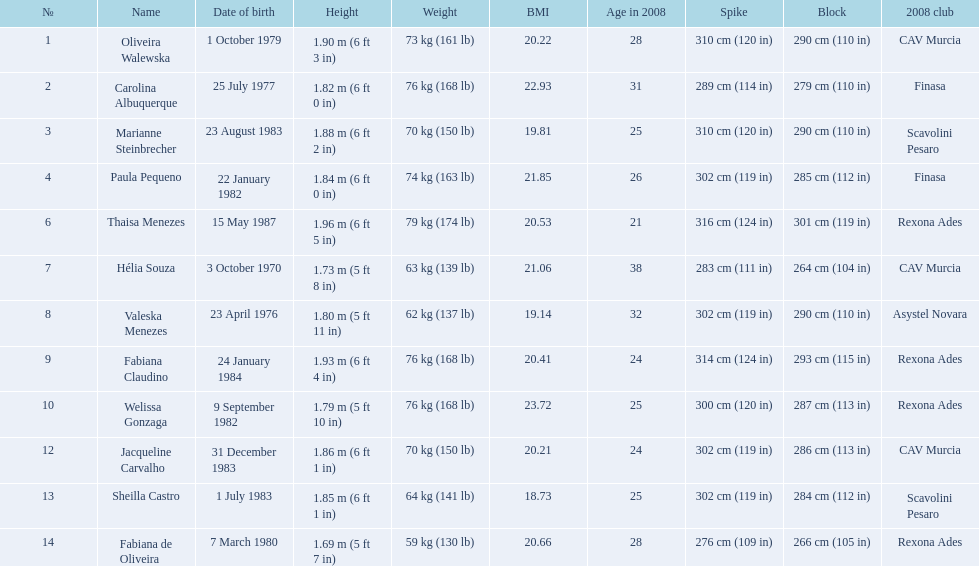What are all of the names? Oliveira Walewska, Carolina Albuquerque, Marianne Steinbrecher, Paula Pequeno, Thaisa Menezes, Hélia Souza, Valeska Menezes, Fabiana Claudino, Welissa Gonzaga, Jacqueline Carvalho, Sheilla Castro, Fabiana de Oliveira. What are their weights? 73 kg (161 lb), 76 kg (168 lb), 70 kg (150 lb), 74 kg (163 lb), 79 kg (174 lb), 63 kg (139 lb), 62 kg (137 lb), 76 kg (168 lb), 76 kg (168 lb), 70 kg (150 lb), 64 kg (141 lb), 59 kg (130 lb). How much did helia souza, fabiana de oliveira, and sheilla castro weigh? Hélia Souza, Sheilla Castro, Fabiana de Oliveira. And who weighed more? Sheilla Castro. 